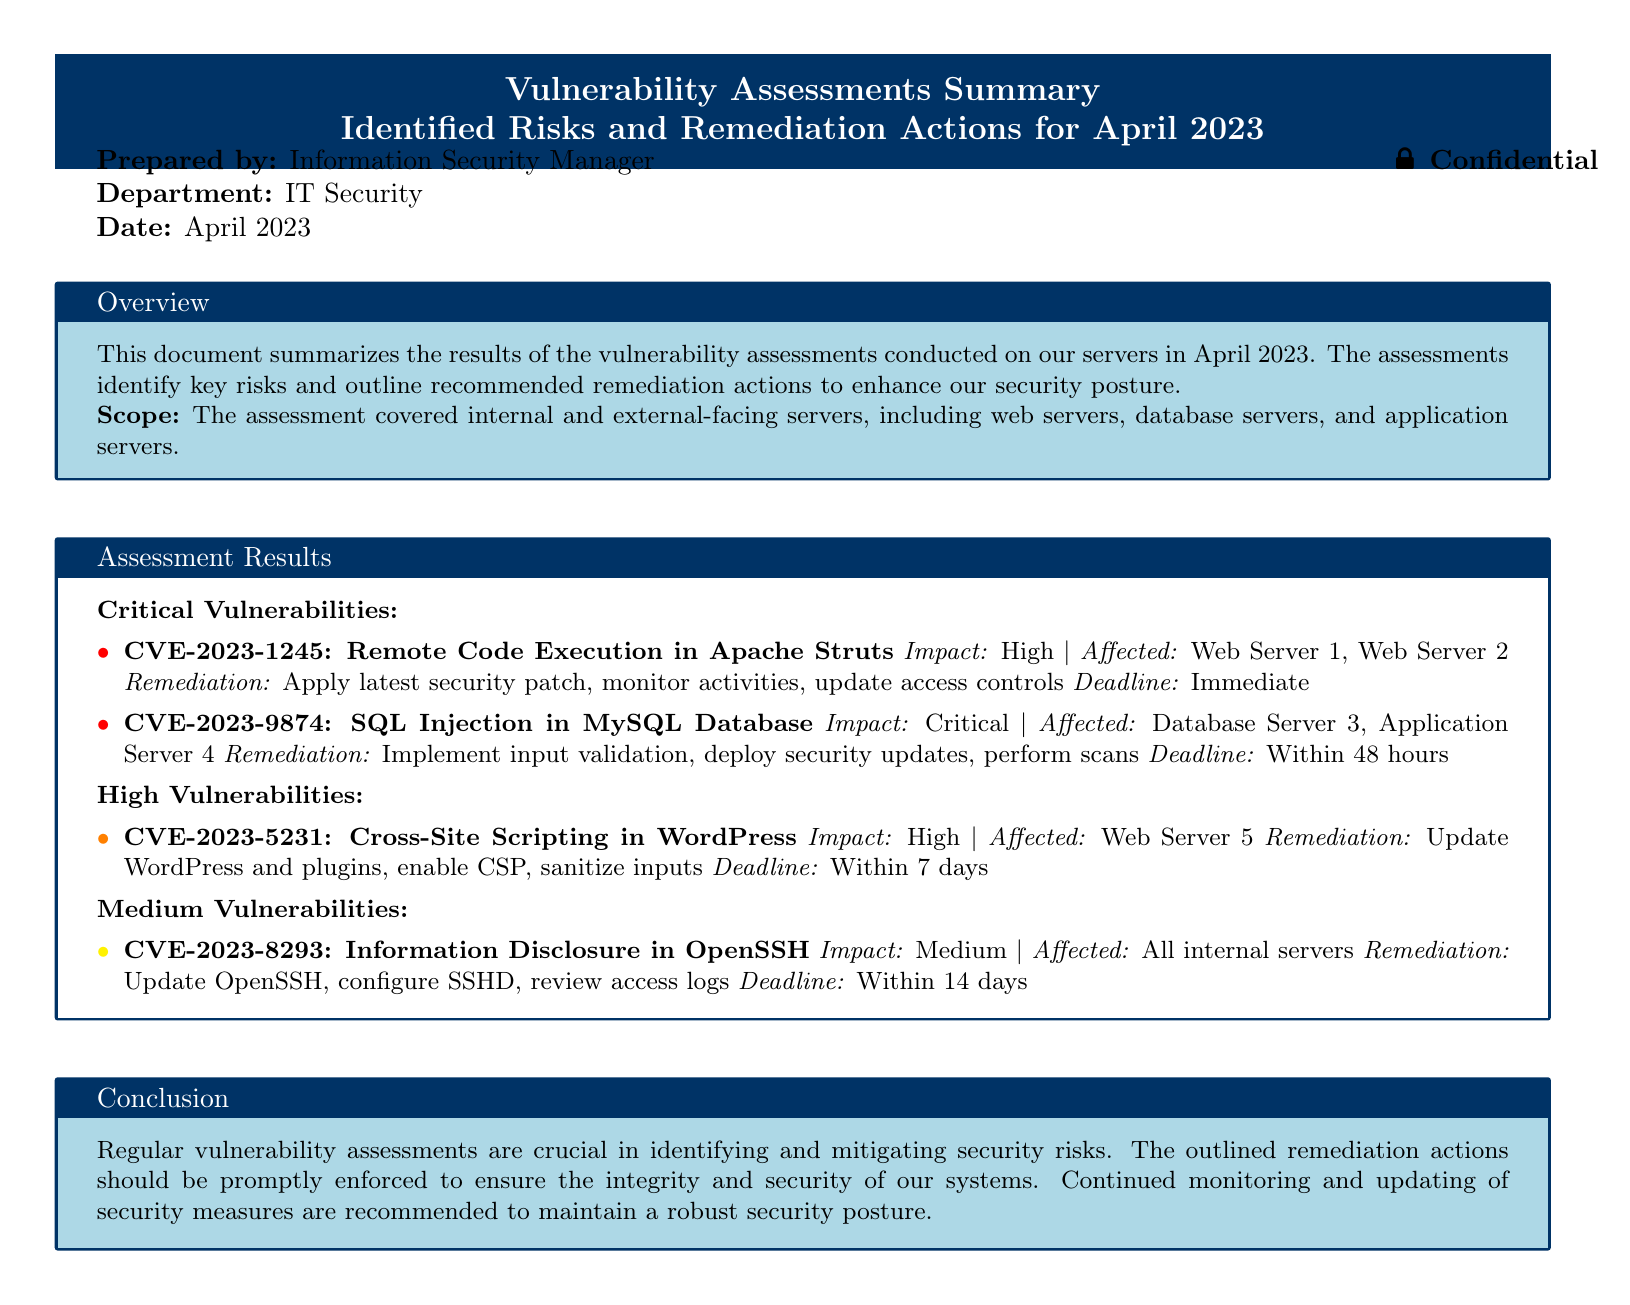What is the date of the assessment summary? The date mentioned in the document for the assessment summary is April 2023.
Answer: April 2023 Who prepared the document? The document indicates that it was prepared by the Information Security Manager.
Answer: Information Security Manager What is the impact level of CVE-2023-9874? The document states that CVE-2023-9874 has a critical impact level.
Answer: Critical What is the remediation deadline for CVE-2023-1245? According to the document, the deadline for remediation of CVE-2023-1245 is immediate.
Answer: Immediate How many critical vulnerabilities are listed in the assessment results? The document lists two critical vulnerabilities identified in the assessment results.
Answer: Two What is the main purpose of regular vulnerability assessments? The conclusion in the document highlights that regular assessments are crucial for identifying and mitigating security risks.
Answer: Identifying and mitigating security risks Which server was affected by the high vulnerability CVE-2023-5231? The document specifies that Web Server 5 was affected by CVE-2023-5231.
Answer: Web Server 5 What remediation action is suggested for the medium vulnerability CVE-2023-8293? The document mentions that one of the remediation actions for CVE-2023-8293 is to update OpenSSH.
Answer: Update OpenSSH 